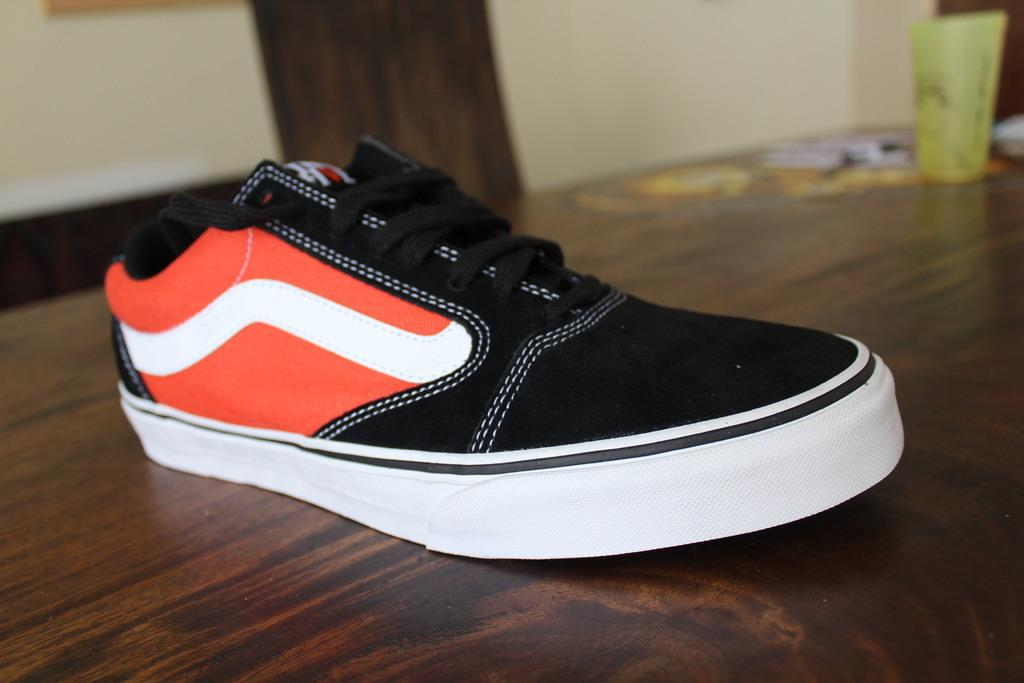What is placed on the table in the image? There is footwear on a table in the image. What is placed on the footwear in the image? There is a glass on the footwear in the image. What can be seen in the background of the image? There is a wall in the background of the image. What type of pies can be seen on the table in the image? There are no pies present on the table in the image. Where is the vase located in the image? There is no vase present in the image. 